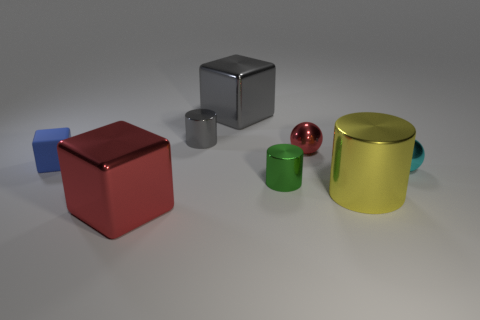What is the shape of the small red metallic object?
Ensure brevity in your answer.  Sphere. Is the number of green metallic things that are behind the small red shiny ball greater than the number of red shiny spheres?
Your answer should be compact. No. The other rubber object that is the same shape as the big red thing is what color?
Provide a succinct answer. Blue. What shape is the tiny thing in front of the tiny cyan object?
Offer a very short reply. Cylinder. Are there any small cylinders right of the small cyan metallic thing?
Offer a very short reply. No. There is another tiny cylinder that is the same material as the small gray cylinder; what color is it?
Give a very brief answer. Green. Does the metal object in front of the large yellow thing have the same color as the shiny sphere on the left side of the cyan metal thing?
Ensure brevity in your answer.  Yes. What number of blocks are either large gray things or small red metal objects?
Keep it short and to the point. 1. Are there an equal number of big yellow cylinders behind the tiny matte object and gray metallic things?
Keep it short and to the point. No. There is a large block right of the red metal object that is to the left of the ball behind the cyan ball; what is its material?
Your answer should be compact. Metal. 